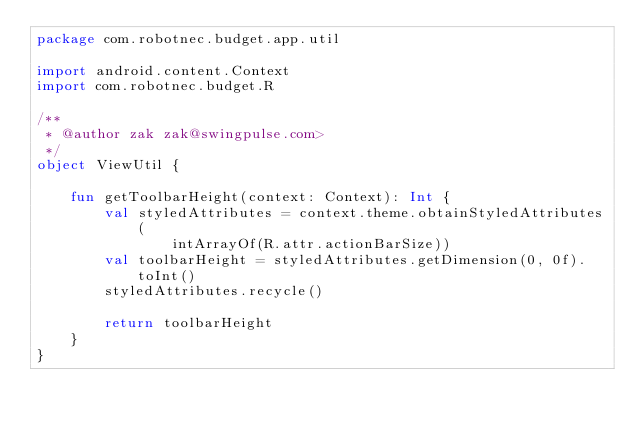Convert code to text. <code><loc_0><loc_0><loc_500><loc_500><_Kotlin_>package com.robotnec.budget.app.util

import android.content.Context
import com.robotnec.budget.R

/**
 * @author zak zak@swingpulse.com>
 */
object ViewUtil {

    fun getToolbarHeight(context: Context): Int {
        val styledAttributes = context.theme.obtainStyledAttributes(
                intArrayOf(R.attr.actionBarSize))
        val toolbarHeight = styledAttributes.getDimension(0, 0f).toInt()
        styledAttributes.recycle()

        return toolbarHeight
    }
}
</code> 